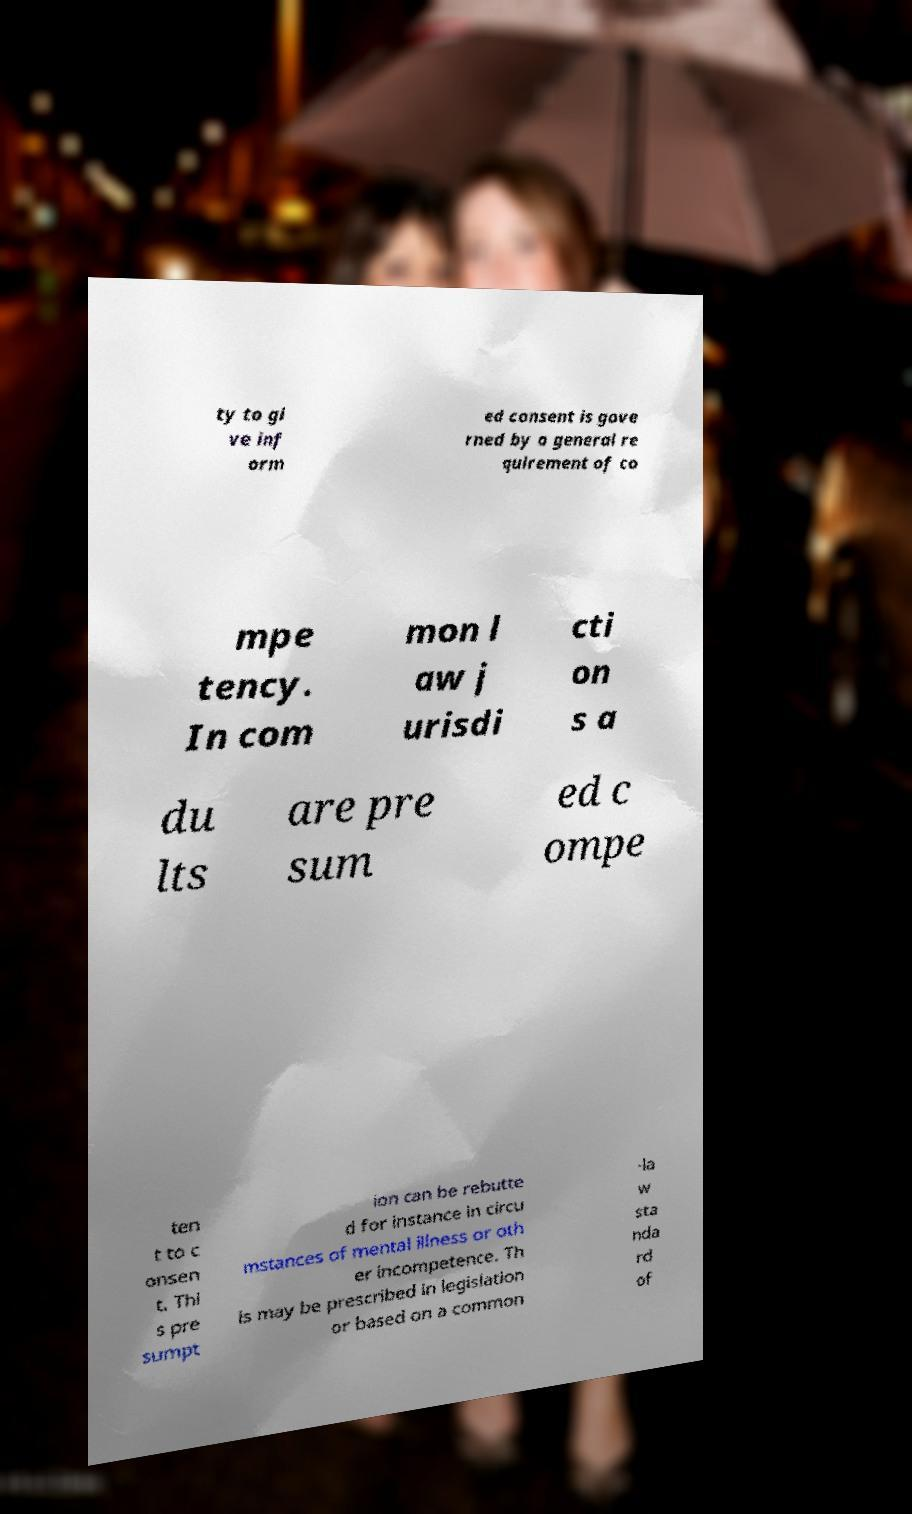What messages or text are displayed in this image? I need them in a readable, typed format. ty to gi ve inf orm ed consent is gove rned by a general re quirement of co mpe tency. In com mon l aw j urisdi cti on s a du lts are pre sum ed c ompe ten t to c onsen t. Thi s pre sumpt ion can be rebutte d for instance in circu mstances of mental illness or oth er incompetence. Th is may be prescribed in legislation or based on a common -la w sta nda rd of 